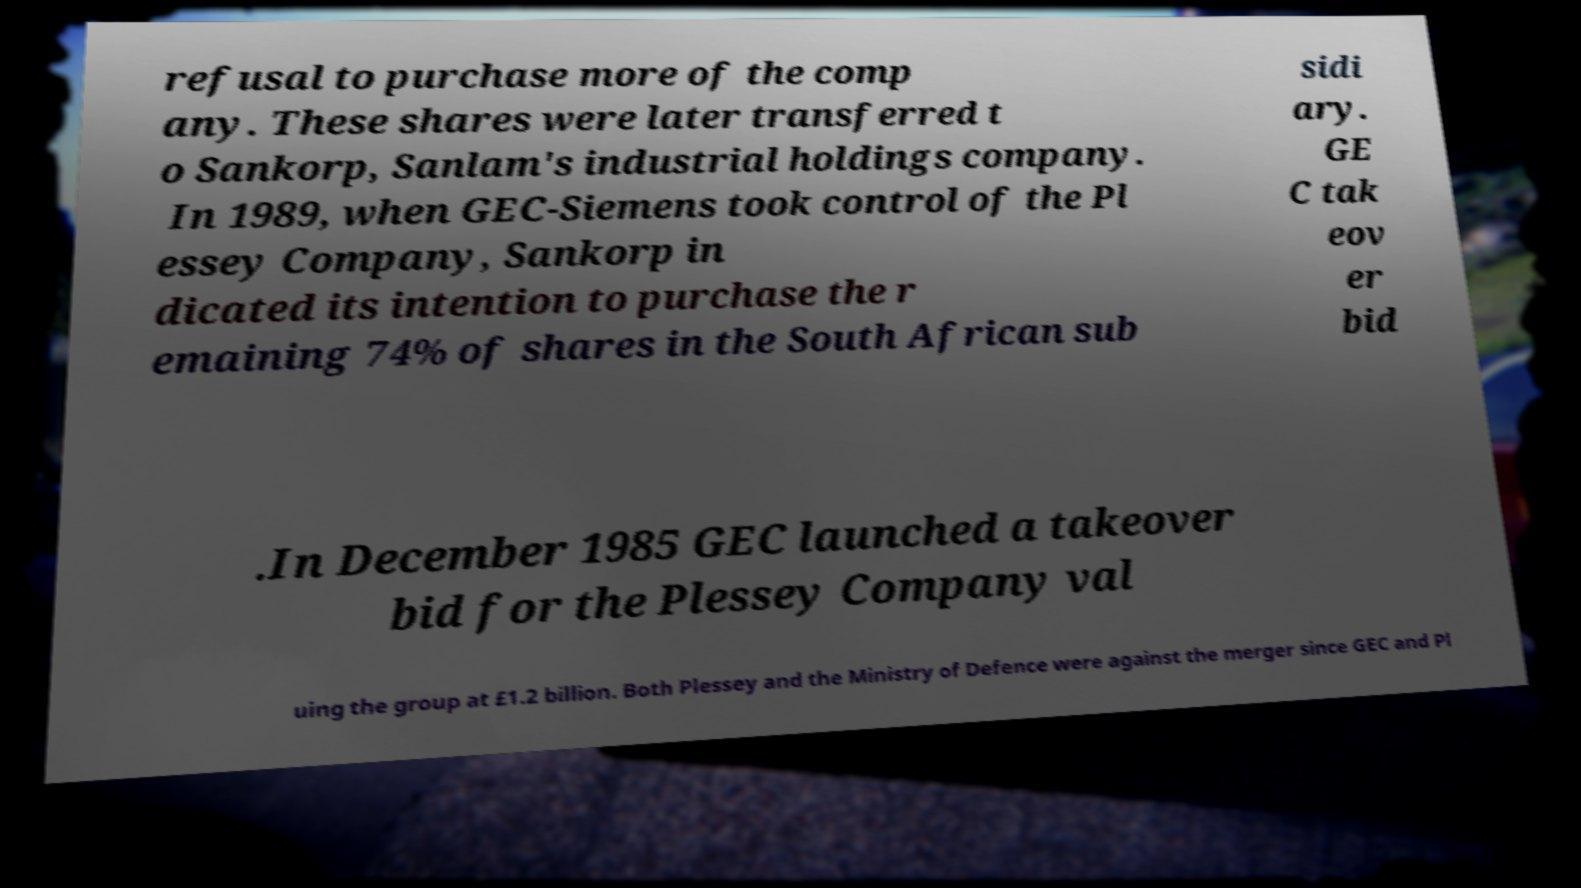What messages or text are displayed in this image? I need them in a readable, typed format. refusal to purchase more of the comp any. These shares were later transferred t o Sankorp, Sanlam's industrial holdings company. In 1989, when GEC-Siemens took control of the Pl essey Company, Sankorp in dicated its intention to purchase the r emaining 74% of shares in the South African sub sidi ary. GE C tak eov er bid .In December 1985 GEC launched a takeover bid for the Plessey Company val uing the group at £1.2 billion. Both Plessey and the Ministry of Defence were against the merger since GEC and Pl 